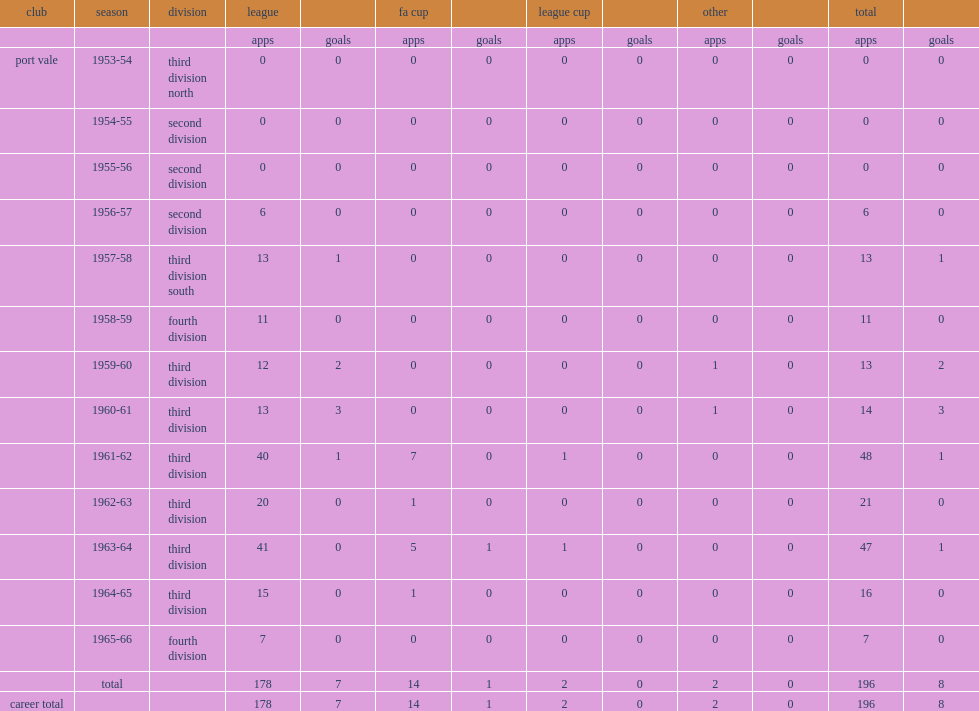How many goals did selwyn whalley score during his 13 years totally? 8.0. 